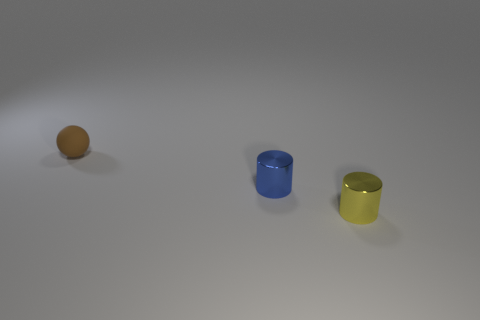Add 2 tiny metallic cylinders. How many objects exist? 5 Subtract all cylinders. How many objects are left? 1 Subtract 0 gray cylinders. How many objects are left? 3 Subtract all big metallic objects. Subtract all tiny spheres. How many objects are left? 2 Add 3 small yellow things. How many small yellow things are left? 4 Add 3 tiny things. How many tiny things exist? 6 